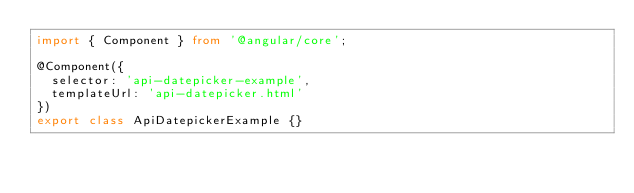<code> <loc_0><loc_0><loc_500><loc_500><_TypeScript_>import { Component } from '@angular/core';

@Component({
	selector: 'api-datepicker-example',
	templateUrl: 'api-datepicker.html'
})
export class ApiDatepickerExample {}</code> 